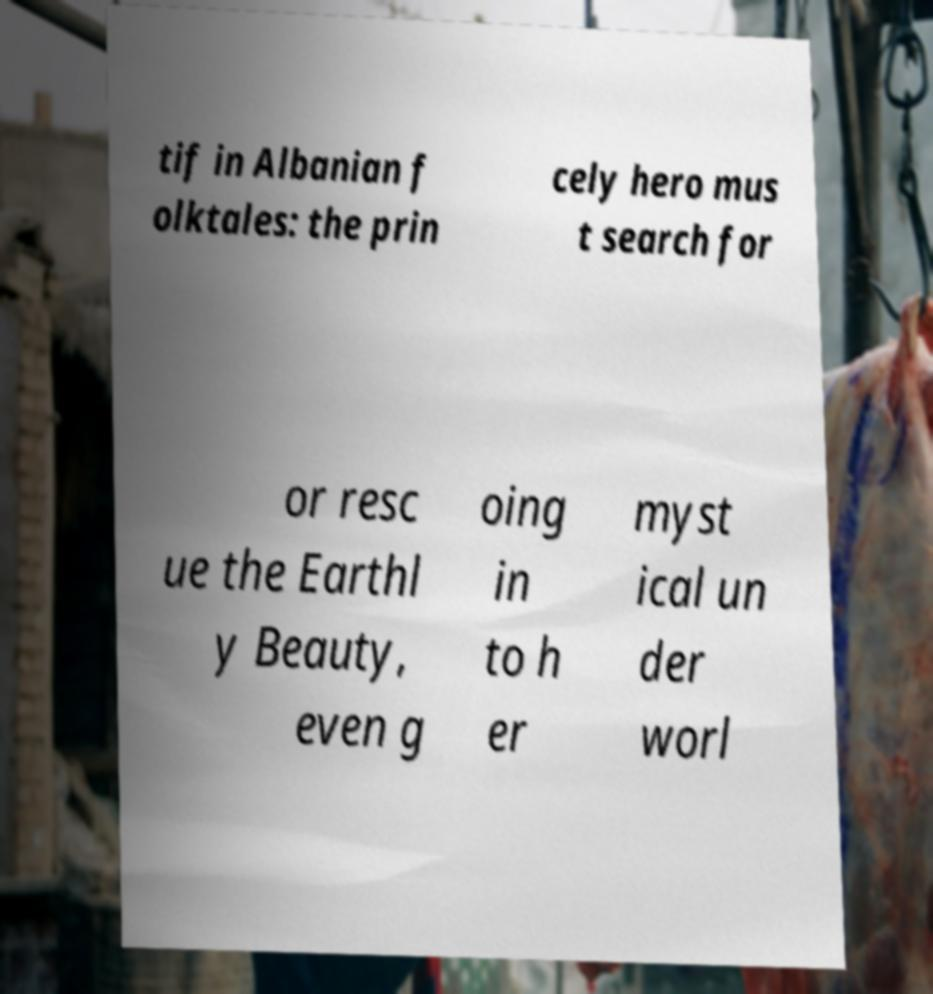For documentation purposes, I need the text within this image transcribed. Could you provide that? tif in Albanian f olktales: the prin cely hero mus t search for or resc ue the Earthl y Beauty, even g oing in to h er myst ical un der worl 